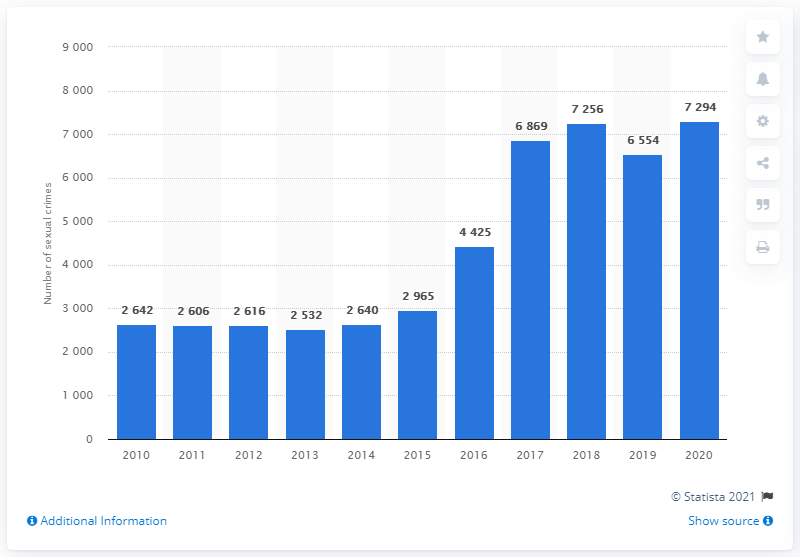Why might there have been a drop in reported sexual crimes from 2014 to 2015? The drop seen in the image between 2014 and 2015 could be caused by various factors. It might be due to changes in legislation, reporting mechanisms, public awareness campaigns, or even natural year-to-year variation. To understand the reasons fully, we would need to look at detailed reports, studies conducted in that period, and possibly the impact of socio-political changes in Denmark. 